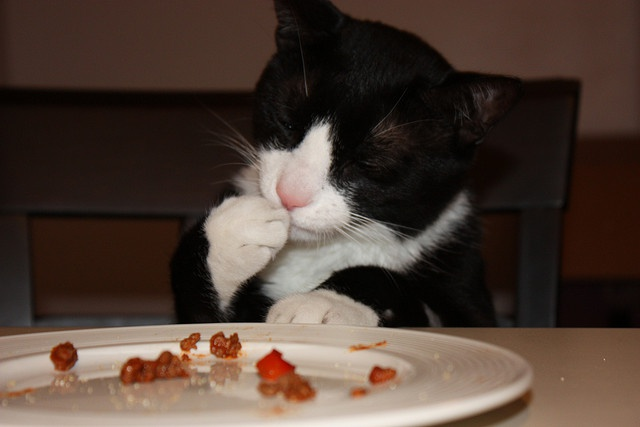Describe the objects in this image and their specific colors. I can see cat in black, darkgray, and gray tones, chair in black, gray, and maroon tones, and dining table in black, tan, and gray tones in this image. 